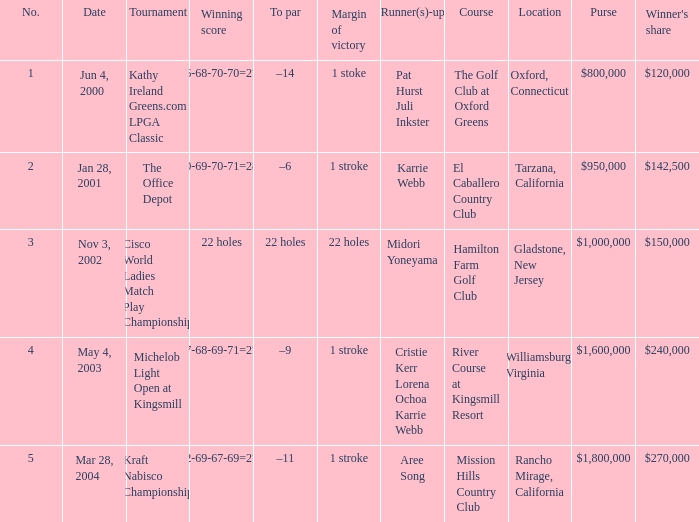Parse the full table. {'header': ['No.', 'Date', 'Tournament', 'Winning score', 'To par', 'Margin of victory', 'Runner(s)-up', 'Course', 'Location', 'Purse', "Winner's share"], 'rows': [['1', 'Jun 4, 2000', 'Kathy Ireland Greens.com LPGA Classic', '66-68-70-70=274', '–14', '1 stoke', 'Pat Hurst Juli Inkster', 'The Golf Club at Oxford Greens', 'Oxford, Connecticut', '$800,000', '$120,000'], ['2', 'Jan 28, 2001', 'The Office Depot', '70-69-70-71=280', '–6', '1 stroke', 'Karrie Webb', 'El Caballero Country Club', 'Tarzana, California', '$950,000', '$142,500'], ['3', 'Nov 3, 2002', 'Cisco World Ladies Match Play Championship', '22 holes', '22 holes', '22 holes', 'Midori Yoneyama', 'Hamilton Farm Golf Club', 'Gladstone, New Jersey', '$1,000,000', '$150,000'], ['4', 'May 4, 2003', 'Michelob Light Open at Kingsmill', '67-68-69-71=275', '–9', '1 stroke', 'Cristie Kerr Lorena Ochoa Karrie Webb', 'River Course at Kingsmill Resort', 'Williamsburg, Virginia', '$1,600,000', '$240,000'], ['5', 'Mar 28, 2004', 'Kraft Nabisco Championship', '72-69-67-69=277', '–11', '1 stroke', 'Aree Song', 'Mission Hills Country Club', 'Rancho Mirage, California', '$1,800,000', '$270,000']]} What date were the runner ups pat hurst juli inkster? Jun 4, 2000. 